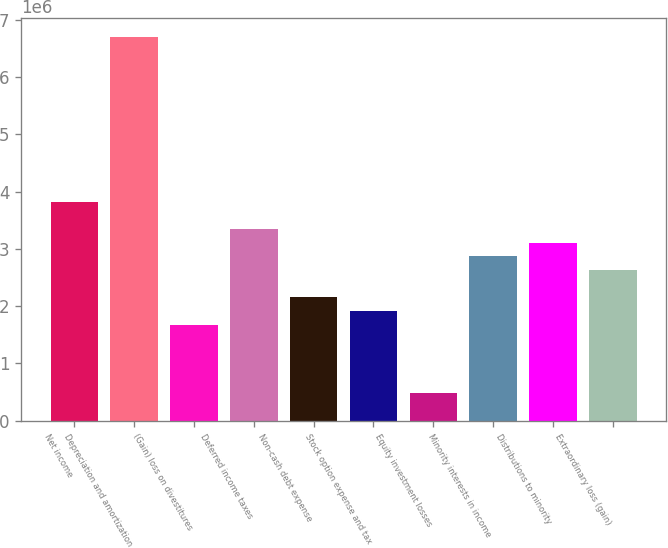Convert chart to OTSL. <chart><loc_0><loc_0><loc_500><loc_500><bar_chart><fcel>Net income<fcel>Depreciation and amortization<fcel>(Gain) loss on divestitures<fcel>Deferred income taxes<fcel>Non-cash debt expense<fcel>Stock option expense and tax<fcel>Equity investment losses<fcel>Minority interests in income<fcel>Distributions to minority<fcel>Extraordinary loss (gain)<nl><fcel>3.82528e+06<fcel>6.69399e+06<fcel>1.67375e+06<fcel>3.34716e+06<fcel>2.15187e+06<fcel>1.91281e+06<fcel>478459<fcel>2.86905e+06<fcel>3.10811e+06<fcel>2.62999e+06<nl></chart> 